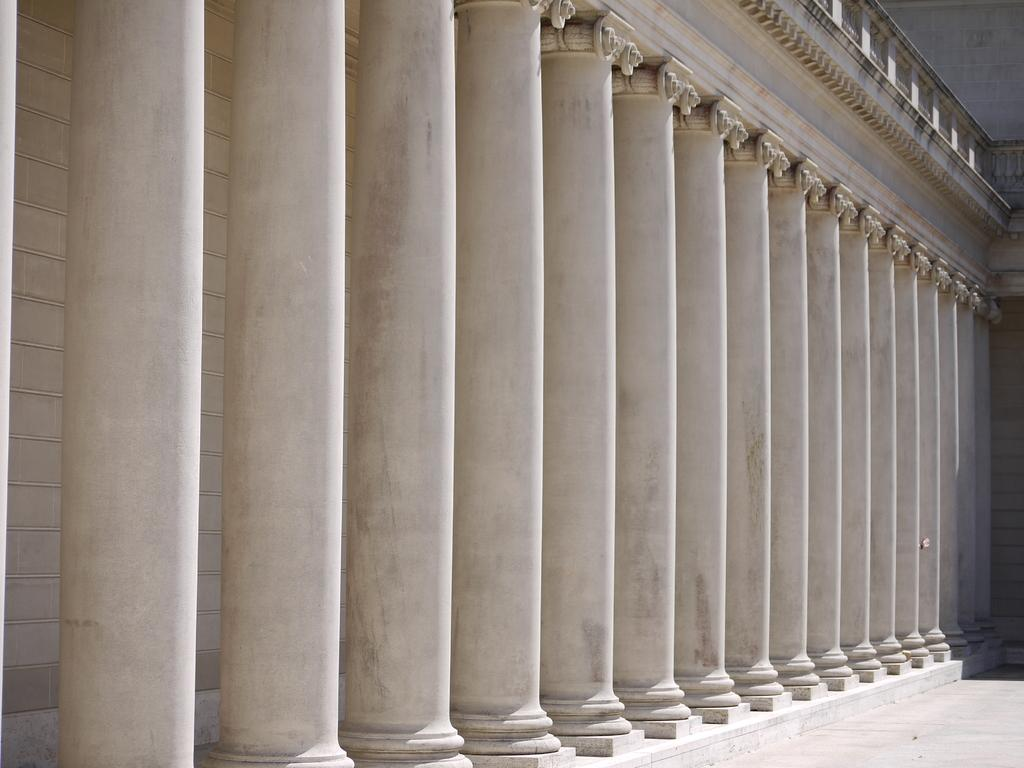What architectural features can be seen in the image? There are pillars and walls in the image. What type of pathway is present in the image? There is a walkway in the image. Where are the carvings located in the image? The carvings are on the right side top of the image. Can you see any eyes on the pillars in the image? There are no eyes present on the pillars in the image. What type of hook can be seen hanging from the walkway in the image? There is no hook present on the walkway in the image. 